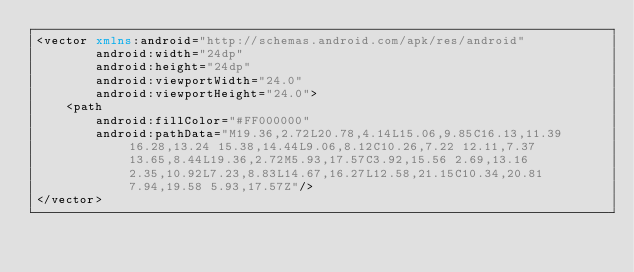<code> <loc_0><loc_0><loc_500><loc_500><_XML_><vector xmlns:android="http://schemas.android.com/apk/res/android"
        android:width="24dp"
        android:height="24dp"
        android:viewportWidth="24.0"
        android:viewportHeight="24.0">
    <path
        android:fillColor="#FF000000"
        android:pathData="M19.36,2.72L20.78,4.14L15.06,9.85C16.13,11.39 16.28,13.24 15.38,14.44L9.06,8.12C10.26,7.22 12.11,7.37 13.65,8.44L19.36,2.72M5.93,17.57C3.92,15.56 2.69,13.16 2.35,10.92L7.23,8.83L14.67,16.27L12.58,21.15C10.34,20.81 7.94,19.58 5.93,17.57Z"/>
</vector>
</code> 